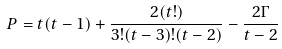<formula> <loc_0><loc_0><loc_500><loc_500>P = t ( t - 1 ) + \frac { 2 ( t ! ) } { 3 ! ( t - 3 ) ! ( t - 2 ) } - \frac { 2 \Gamma } { t - 2 }</formula> 